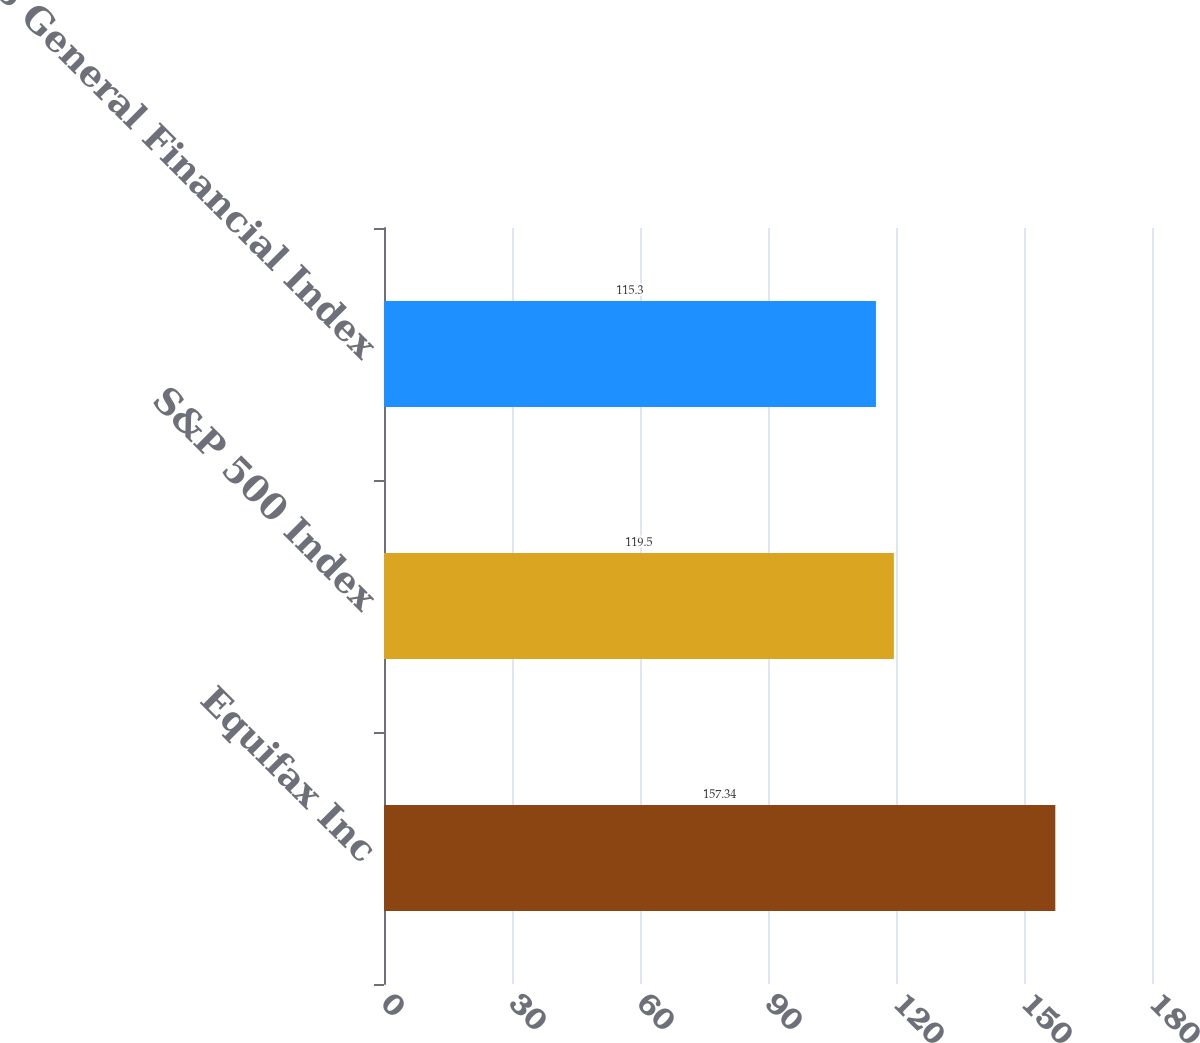<chart> <loc_0><loc_0><loc_500><loc_500><bar_chart><fcel>Equifax Inc<fcel>S&P 500 Index<fcel>DJ US General Financial Index<nl><fcel>157.34<fcel>119.5<fcel>115.3<nl></chart> 